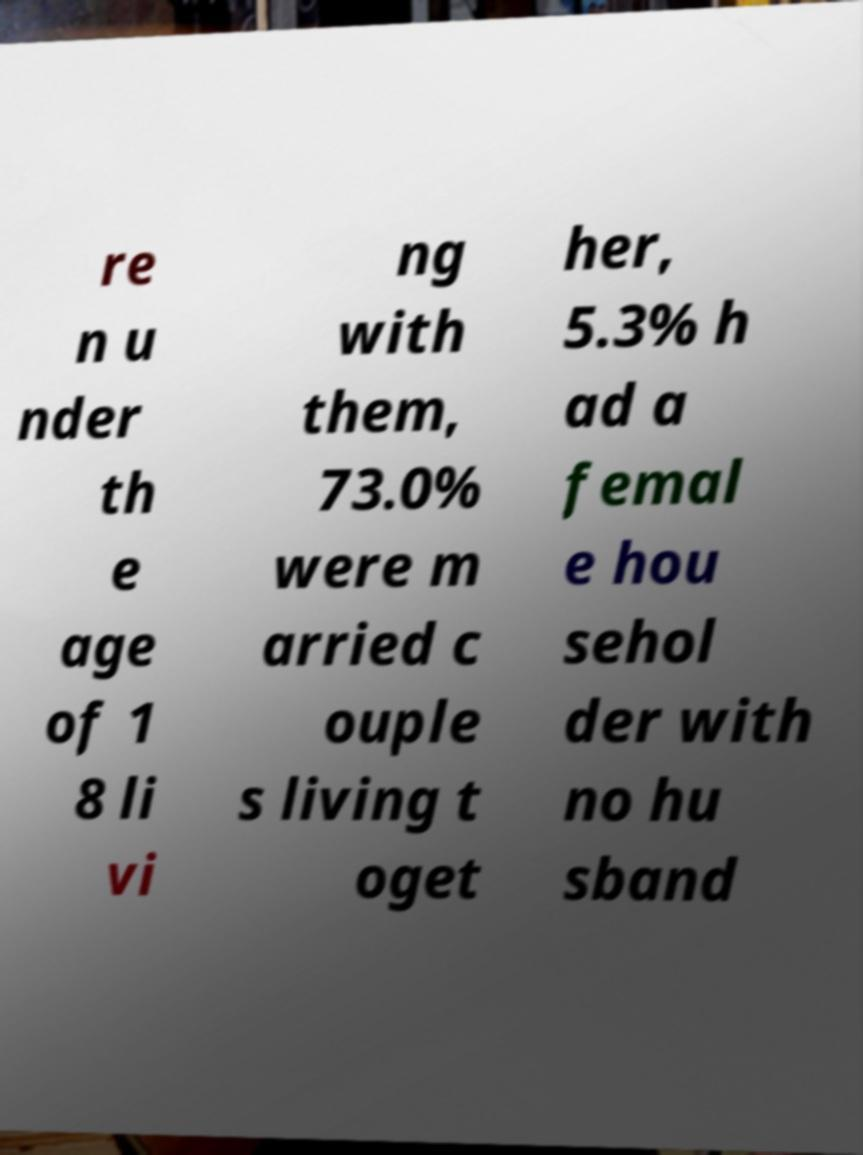Can you read and provide the text displayed in the image?This photo seems to have some interesting text. Can you extract and type it out for me? re n u nder th e age of 1 8 li vi ng with them, 73.0% were m arried c ouple s living t oget her, 5.3% h ad a femal e hou sehol der with no hu sband 